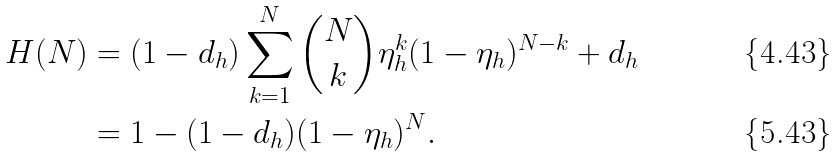<formula> <loc_0><loc_0><loc_500><loc_500>H ( N ) & = ( 1 - d _ { h } ) \sum _ { k = 1 } ^ { N } \binom { N } { k } \eta _ { h } ^ { k } ( 1 - \eta _ { h } ) ^ { N - k } + d _ { h } \\ & = 1 - ( 1 - d _ { h } ) ( 1 - \eta _ { h } ) ^ { N } .</formula> 